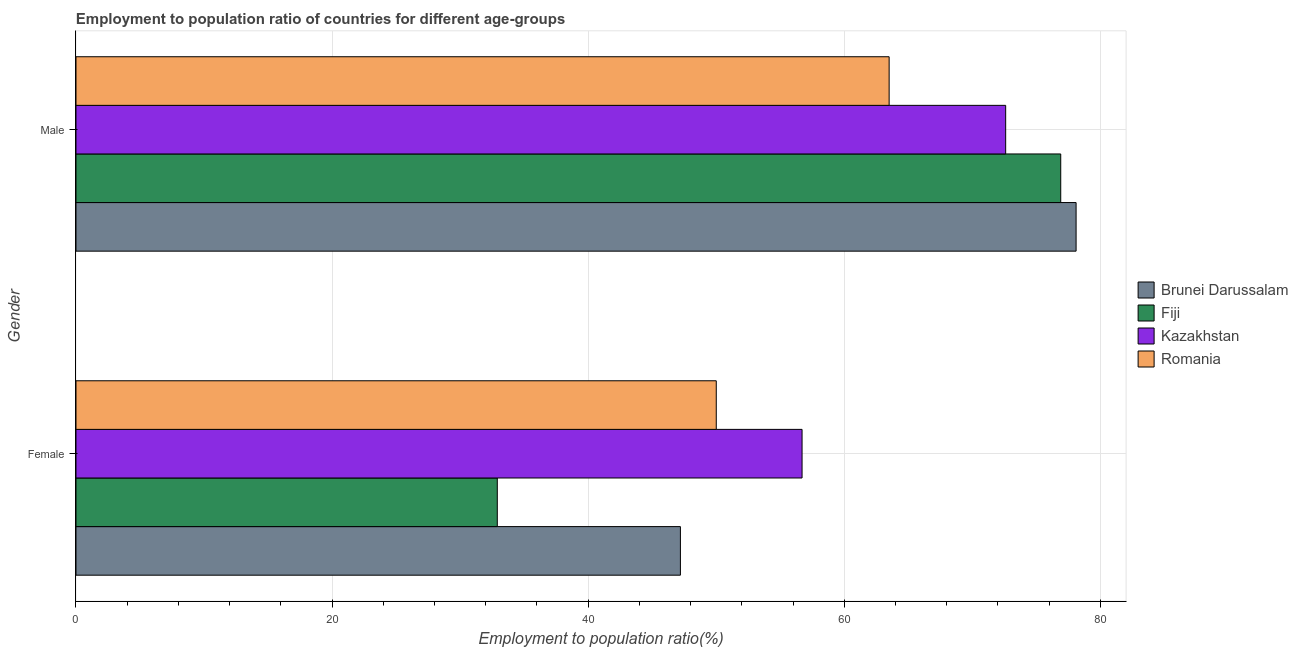Are the number of bars per tick equal to the number of legend labels?
Offer a very short reply. Yes. What is the label of the 1st group of bars from the top?
Offer a terse response. Male. What is the employment to population ratio(female) in Brunei Darussalam?
Make the answer very short. 47.2. Across all countries, what is the maximum employment to population ratio(male)?
Make the answer very short. 78.1. Across all countries, what is the minimum employment to population ratio(female)?
Provide a short and direct response. 32.9. In which country was the employment to population ratio(female) maximum?
Your answer should be very brief. Kazakhstan. In which country was the employment to population ratio(female) minimum?
Your answer should be very brief. Fiji. What is the total employment to population ratio(female) in the graph?
Offer a terse response. 186.8. What is the difference between the employment to population ratio(female) in Fiji and that in Romania?
Provide a succinct answer. -17.1. What is the difference between the employment to population ratio(female) in Kazakhstan and the employment to population ratio(male) in Fiji?
Offer a terse response. -20.2. What is the average employment to population ratio(female) per country?
Ensure brevity in your answer.  46.7. What is the difference between the employment to population ratio(female) and employment to population ratio(male) in Brunei Darussalam?
Offer a terse response. -30.9. In how many countries, is the employment to population ratio(male) greater than 40 %?
Your answer should be very brief. 4. What is the ratio of the employment to population ratio(male) in Romania to that in Fiji?
Keep it short and to the point. 0.83. What does the 3rd bar from the top in Male represents?
Provide a short and direct response. Fiji. What does the 3rd bar from the bottom in Male represents?
Your answer should be very brief. Kazakhstan. Are all the bars in the graph horizontal?
Make the answer very short. Yes. How many countries are there in the graph?
Offer a terse response. 4. What is the difference between two consecutive major ticks on the X-axis?
Make the answer very short. 20. Does the graph contain grids?
Your answer should be very brief. Yes. What is the title of the graph?
Ensure brevity in your answer.  Employment to population ratio of countries for different age-groups. What is the label or title of the X-axis?
Offer a very short reply. Employment to population ratio(%). What is the label or title of the Y-axis?
Make the answer very short. Gender. What is the Employment to population ratio(%) of Brunei Darussalam in Female?
Offer a very short reply. 47.2. What is the Employment to population ratio(%) of Fiji in Female?
Give a very brief answer. 32.9. What is the Employment to population ratio(%) of Kazakhstan in Female?
Your response must be concise. 56.7. What is the Employment to population ratio(%) of Romania in Female?
Your answer should be compact. 50. What is the Employment to population ratio(%) of Brunei Darussalam in Male?
Your answer should be very brief. 78.1. What is the Employment to population ratio(%) of Fiji in Male?
Provide a succinct answer. 76.9. What is the Employment to population ratio(%) in Kazakhstan in Male?
Offer a very short reply. 72.6. What is the Employment to population ratio(%) of Romania in Male?
Keep it short and to the point. 63.5. Across all Gender, what is the maximum Employment to population ratio(%) of Brunei Darussalam?
Offer a very short reply. 78.1. Across all Gender, what is the maximum Employment to population ratio(%) in Fiji?
Offer a very short reply. 76.9. Across all Gender, what is the maximum Employment to population ratio(%) in Kazakhstan?
Make the answer very short. 72.6. Across all Gender, what is the maximum Employment to population ratio(%) in Romania?
Offer a terse response. 63.5. Across all Gender, what is the minimum Employment to population ratio(%) of Brunei Darussalam?
Your response must be concise. 47.2. Across all Gender, what is the minimum Employment to population ratio(%) of Fiji?
Provide a succinct answer. 32.9. Across all Gender, what is the minimum Employment to population ratio(%) in Kazakhstan?
Ensure brevity in your answer.  56.7. Across all Gender, what is the minimum Employment to population ratio(%) of Romania?
Make the answer very short. 50. What is the total Employment to population ratio(%) in Brunei Darussalam in the graph?
Offer a terse response. 125.3. What is the total Employment to population ratio(%) in Fiji in the graph?
Your answer should be compact. 109.8. What is the total Employment to population ratio(%) of Kazakhstan in the graph?
Your answer should be compact. 129.3. What is the total Employment to population ratio(%) of Romania in the graph?
Keep it short and to the point. 113.5. What is the difference between the Employment to population ratio(%) in Brunei Darussalam in Female and that in Male?
Your answer should be compact. -30.9. What is the difference between the Employment to population ratio(%) of Fiji in Female and that in Male?
Keep it short and to the point. -44. What is the difference between the Employment to population ratio(%) of Kazakhstan in Female and that in Male?
Provide a short and direct response. -15.9. What is the difference between the Employment to population ratio(%) of Romania in Female and that in Male?
Provide a succinct answer. -13.5. What is the difference between the Employment to population ratio(%) of Brunei Darussalam in Female and the Employment to population ratio(%) of Fiji in Male?
Ensure brevity in your answer.  -29.7. What is the difference between the Employment to population ratio(%) in Brunei Darussalam in Female and the Employment to population ratio(%) in Kazakhstan in Male?
Keep it short and to the point. -25.4. What is the difference between the Employment to population ratio(%) of Brunei Darussalam in Female and the Employment to population ratio(%) of Romania in Male?
Keep it short and to the point. -16.3. What is the difference between the Employment to population ratio(%) of Fiji in Female and the Employment to population ratio(%) of Kazakhstan in Male?
Offer a very short reply. -39.7. What is the difference between the Employment to population ratio(%) in Fiji in Female and the Employment to population ratio(%) in Romania in Male?
Your response must be concise. -30.6. What is the difference between the Employment to population ratio(%) of Kazakhstan in Female and the Employment to population ratio(%) of Romania in Male?
Offer a terse response. -6.8. What is the average Employment to population ratio(%) in Brunei Darussalam per Gender?
Offer a terse response. 62.65. What is the average Employment to population ratio(%) of Fiji per Gender?
Provide a succinct answer. 54.9. What is the average Employment to population ratio(%) in Kazakhstan per Gender?
Your response must be concise. 64.65. What is the average Employment to population ratio(%) in Romania per Gender?
Give a very brief answer. 56.75. What is the difference between the Employment to population ratio(%) of Brunei Darussalam and Employment to population ratio(%) of Fiji in Female?
Ensure brevity in your answer.  14.3. What is the difference between the Employment to population ratio(%) in Fiji and Employment to population ratio(%) in Kazakhstan in Female?
Provide a succinct answer. -23.8. What is the difference between the Employment to population ratio(%) of Fiji and Employment to population ratio(%) of Romania in Female?
Provide a succinct answer. -17.1. What is the difference between the Employment to population ratio(%) in Brunei Darussalam and Employment to population ratio(%) in Fiji in Male?
Give a very brief answer. 1.2. What is the difference between the Employment to population ratio(%) of Brunei Darussalam and Employment to population ratio(%) of Romania in Male?
Offer a terse response. 14.6. What is the difference between the Employment to population ratio(%) of Fiji and Employment to population ratio(%) of Kazakhstan in Male?
Give a very brief answer. 4.3. What is the ratio of the Employment to population ratio(%) of Brunei Darussalam in Female to that in Male?
Your answer should be very brief. 0.6. What is the ratio of the Employment to population ratio(%) of Fiji in Female to that in Male?
Offer a very short reply. 0.43. What is the ratio of the Employment to population ratio(%) in Kazakhstan in Female to that in Male?
Provide a short and direct response. 0.78. What is the ratio of the Employment to population ratio(%) in Romania in Female to that in Male?
Give a very brief answer. 0.79. What is the difference between the highest and the second highest Employment to population ratio(%) of Brunei Darussalam?
Keep it short and to the point. 30.9. What is the difference between the highest and the second highest Employment to population ratio(%) in Kazakhstan?
Your answer should be compact. 15.9. What is the difference between the highest and the lowest Employment to population ratio(%) of Brunei Darussalam?
Provide a succinct answer. 30.9. What is the difference between the highest and the lowest Employment to population ratio(%) of Romania?
Keep it short and to the point. 13.5. 